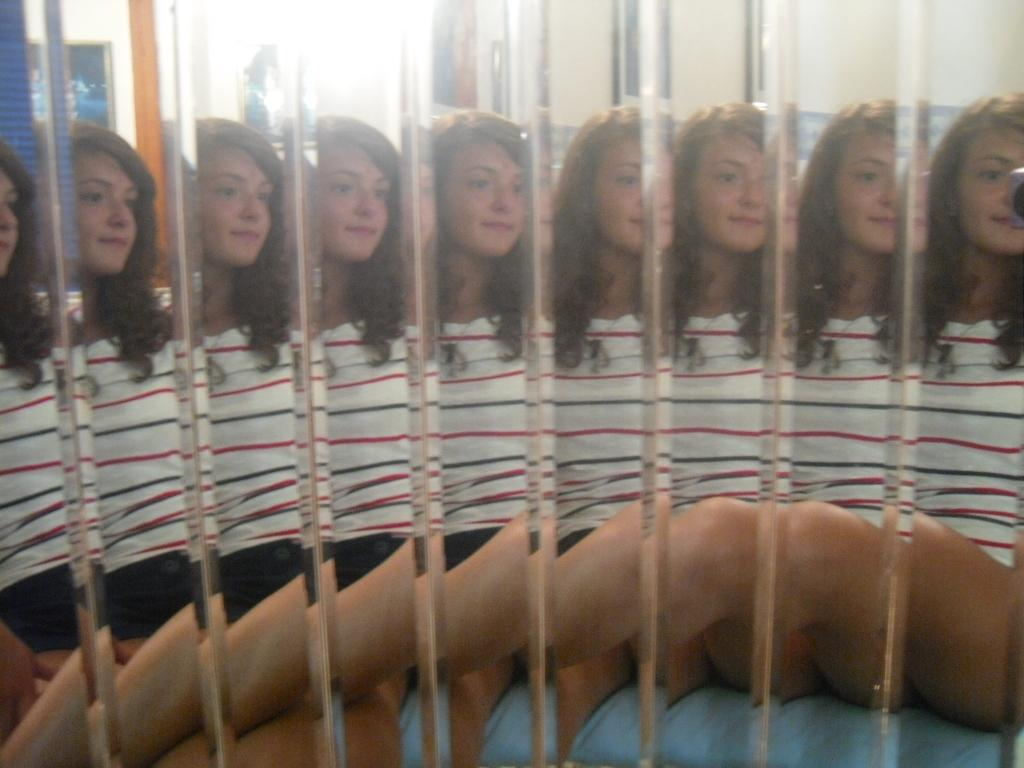What is the main subject of the image? The main subject of the image is a woman. How is the woman represented in the image? There are multiple reflections of the woman in the image. On what surface are the reflections visible? The reflections are on a mirror. What type of canvas is the woman painting on in the image? There is no canvas or painting activity present in the image; it features a woman with multiple reflections on a mirror. 